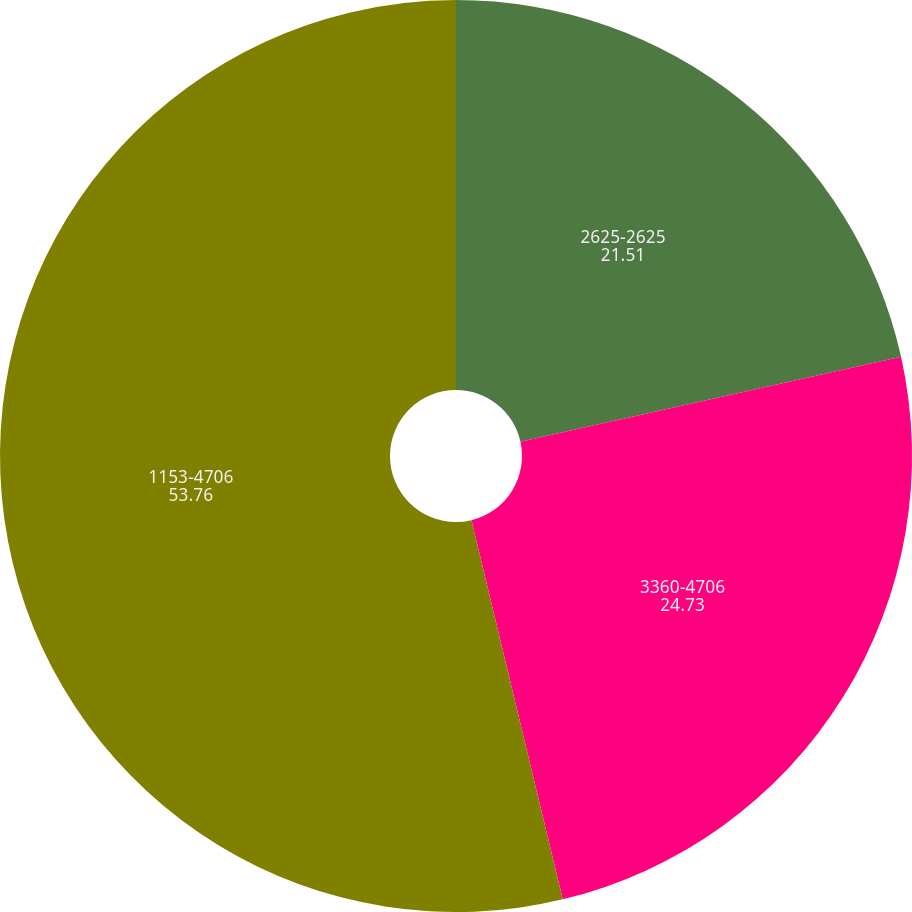<chart> <loc_0><loc_0><loc_500><loc_500><pie_chart><fcel>2625-2625<fcel>3360-4706<fcel>1153-4706<nl><fcel>21.51%<fcel>24.73%<fcel>53.76%<nl></chart> 